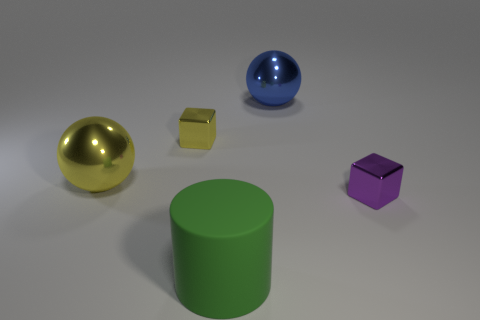Add 2 balls. How many objects exist? 7 Subtract all spheres. How many objects are left? 3 Subtract all large yellow shiny objects. Subtract all large blue shiny spheres. How many objects are left? 3 Add 2 big green cylinders. How many big green cylinders are left? 3 Add 4 large yellow metal balls. How many large yellow metal balls exist? 5 Subtract 0 red cylinders. How many objects are left? 5 